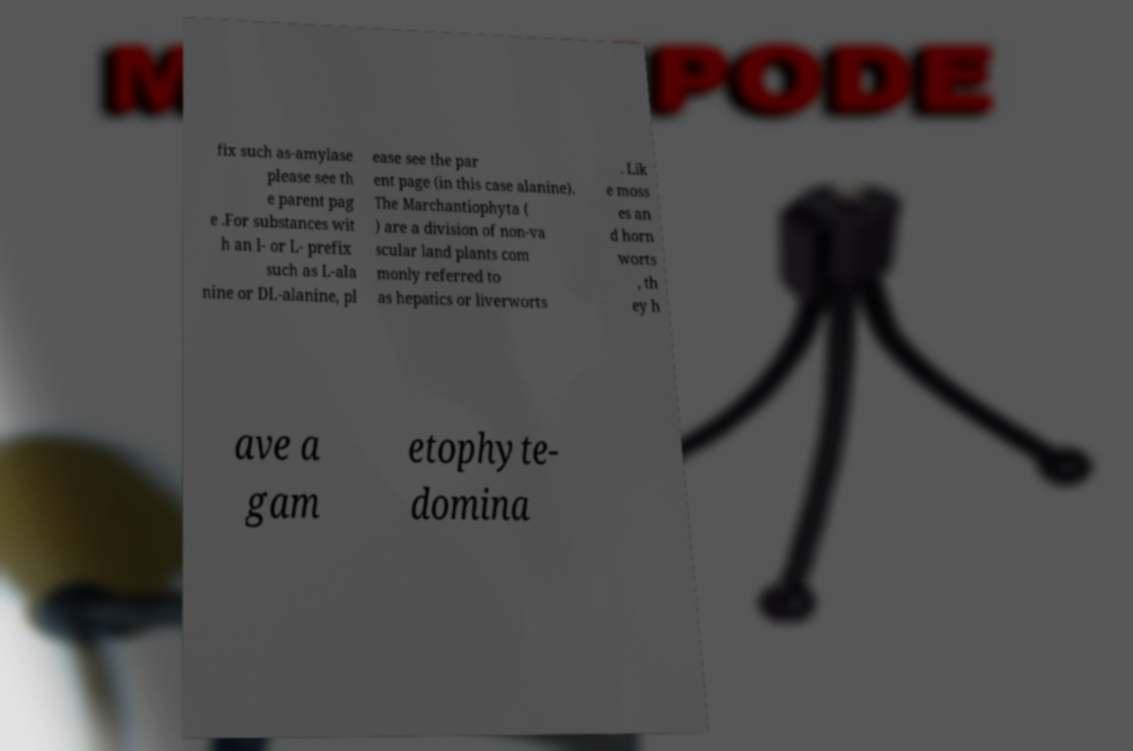Could you extract and type out the text from this image? fix such as-amylase please see th e parent pag e .For substances wit h an l- or L- prefix such as L-ala nine or DL-alanine, pl ease see the par ent page (in this case alanine). The Marchantiophyta ( ) are a division of non-va scular land plants com monly referred to as hepatics or liverworts . Lik e moss es an d horn worts , th ey h ave a gam etophyte- domina 